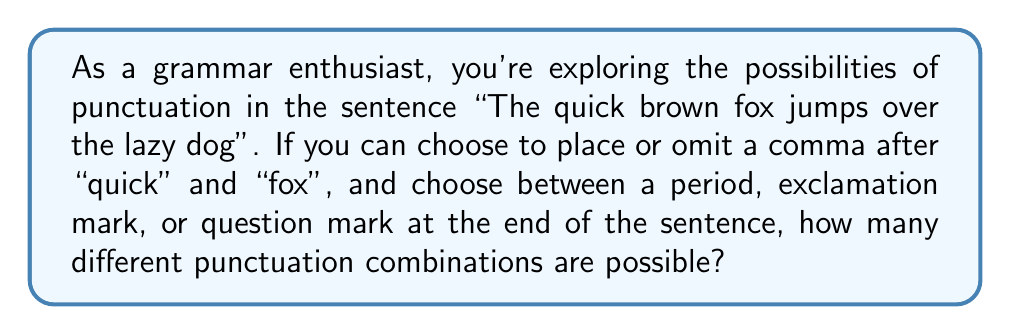Help me with this question. Let's break this down step-by-step:

1) First, let's consider the commas. We have two positions where we can choose to place or omit a comma:
   - After "quick"
   - After "fox"

   For each position, we have 2 choices (comma or no comma).
   Therefore, we have $2 \times 2 = 4$ possible comma combinations.

2) Now, for the end of the sentence, we have 3 choices:
   - Period (.)
   - Exclamation mark (!)
   - Question mark (?)

3) To find the total number of combinations, we multiply the number of comma combinations by the number of end punctuation choices:

   $$ \text{Total combinations} = \text{Comma combinations} \times \text{End punctuation choices} $$
   $$ \text{Total combinations} = 4 \times 3 = 12 $$

Therefore, there are 12 possible punctuation combinations for this sentence.
Answer: 12 combinations 